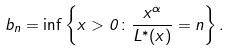<formula> <loc_0><loc_0><loc_500><loc_500>b _ { n } = \inf \left \{ x > 0 \colon \frac { x ^ { \alpha } } { L ^ { * } ( x ) } = n \right \} .</formula> 